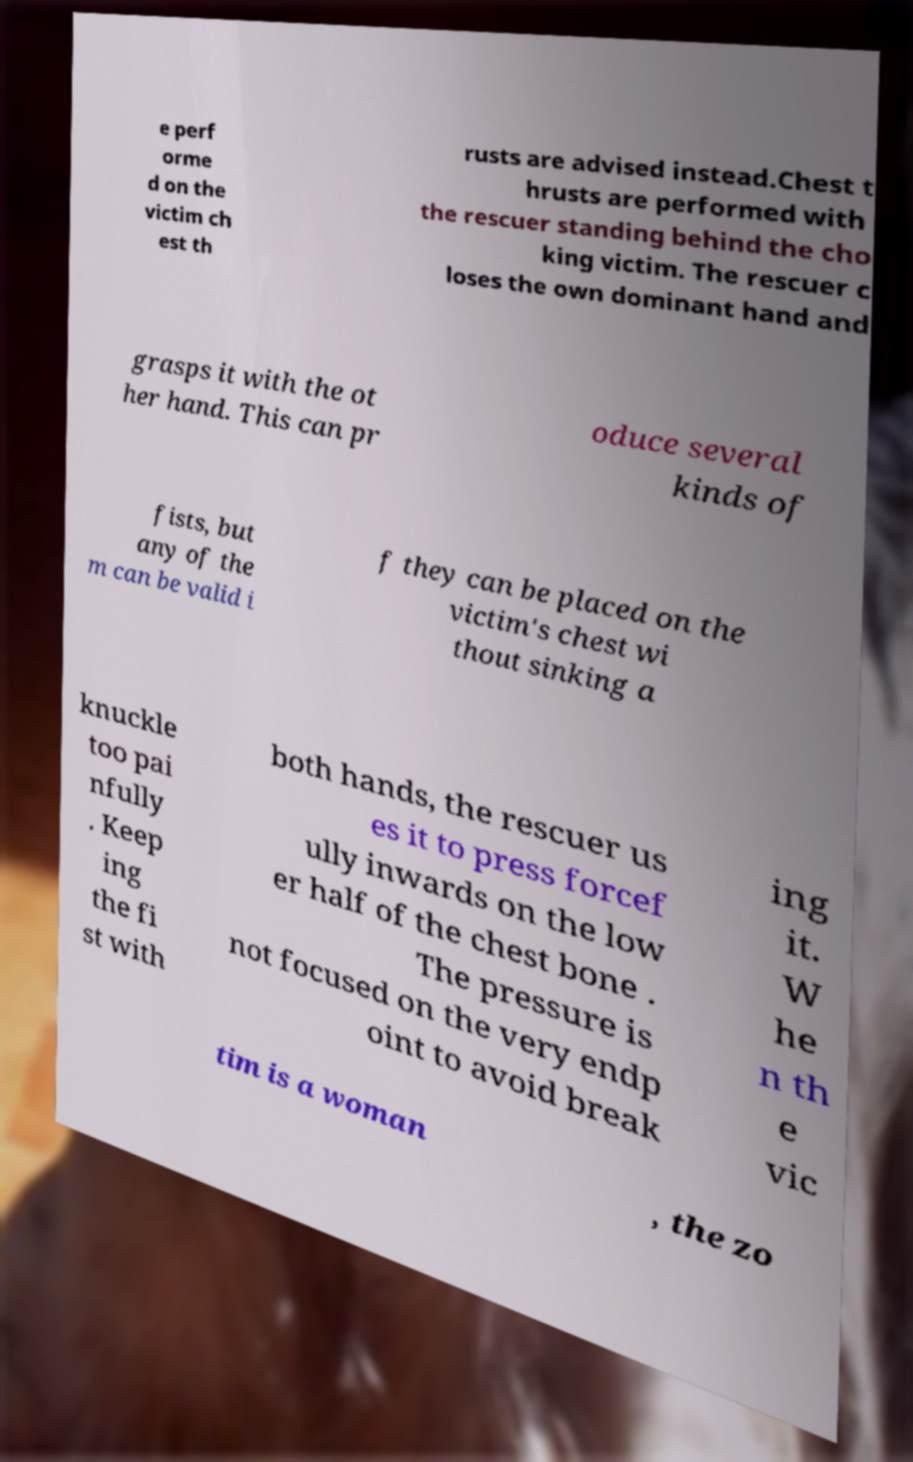Please read and relay the text visible in this image. What does it say? e perf orme d on the victim ch est th rusts are advised instead.Chest t hrusts are performed with the rescuer standing behind the cho king victim. The rescuer c loses the own dominant hand and grasps it with the ot her hand. This can pr oduce several kinds of fists, but any of the m can be valid i f they can be placed on the victim's chest wi thout sinking a knuckle too pai nfully . Keep ing the fi st with both hands, the rescuer us es it to press forcef ully inwards on the low er half of the chest bone . The pressure is not focused on the very endp oint to avoid break ing it. W he n th e vic tim is a woman , the zo 